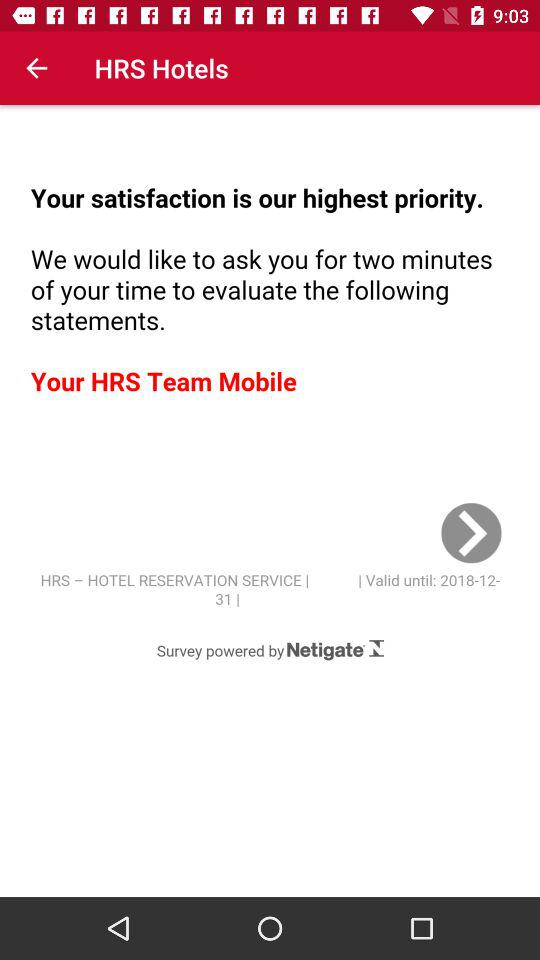By whom is the survey powered? The survey is powered by netigate. 